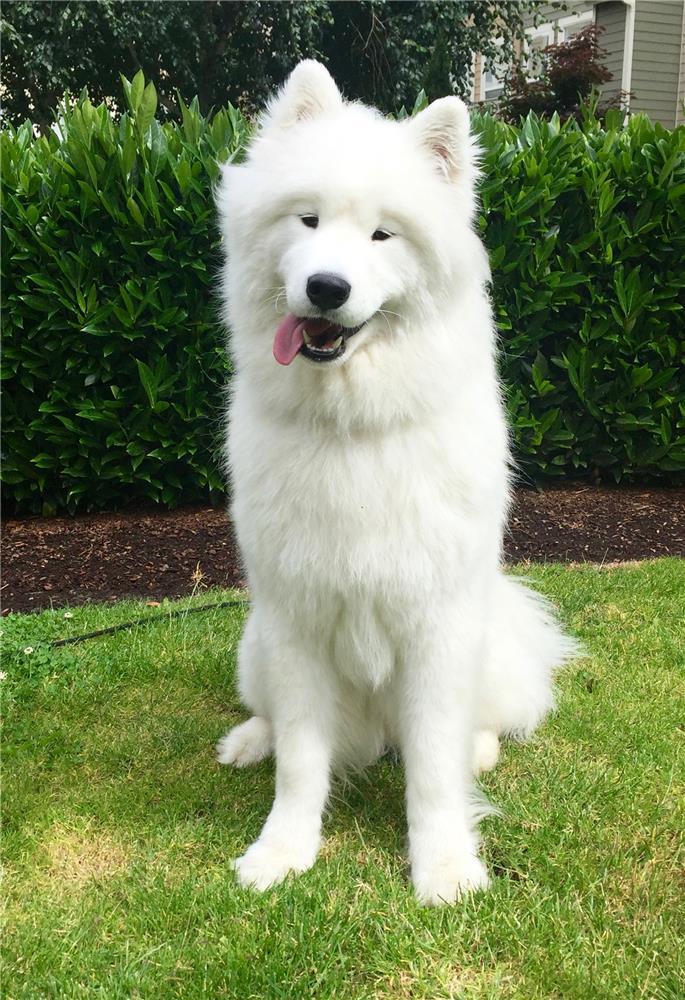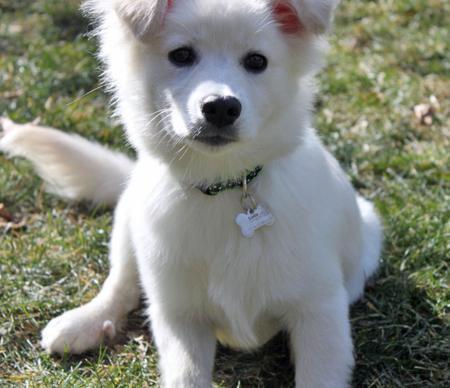The first image is the image on the left, the second image is the image on the right. For the images displayed, is the sentence "One white dog is shown with flowers in the background in one image." factually correct? Answer yes or no. No. The first image is the image on the left, the second image is the image on the right. Examine the images to the left and right. Is the description "There is a flowering plant behind one of the dogs." accurate? Answer yes or no. No. 